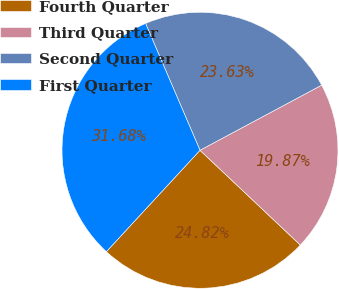<chart> <loc_0><loc_0><loc_500><loc_500><pie_chart><fcel>Fourth Quarter<fcel>Third Quarter<fcel>Second Quarter<fcel>First Quarter<nl><fcel>24.82%<fcel>19.87%<fcel>23.63%<fcel>31.68%<nl></chart> 